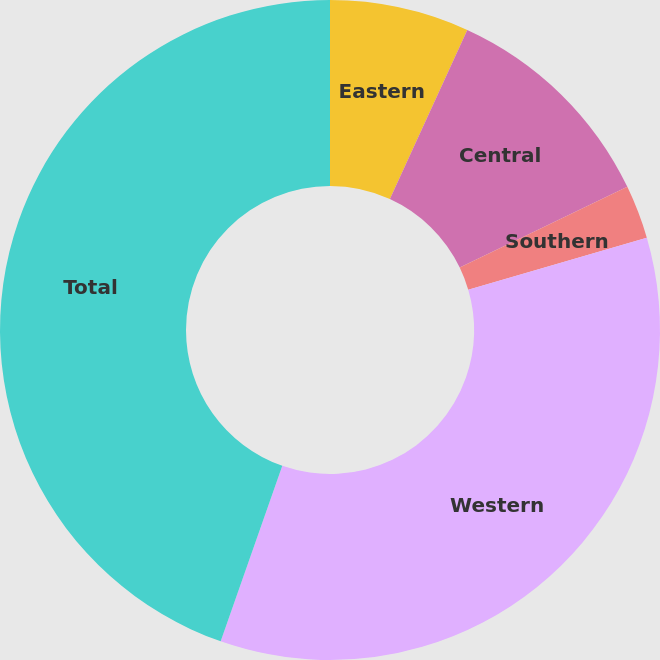Convert chart to OTSL. <chart><loc_0><loc_0><loc_500><loc_500><pie_chart><fcel>Eastern<fcel>Central<fcel>Southern<fcel>Western<fcel>Total<nl><fcel>6.83%<fcel>11.03%<fcel>2.63%<fcel>34.89%<fcel>44.63%<nl></chart> 